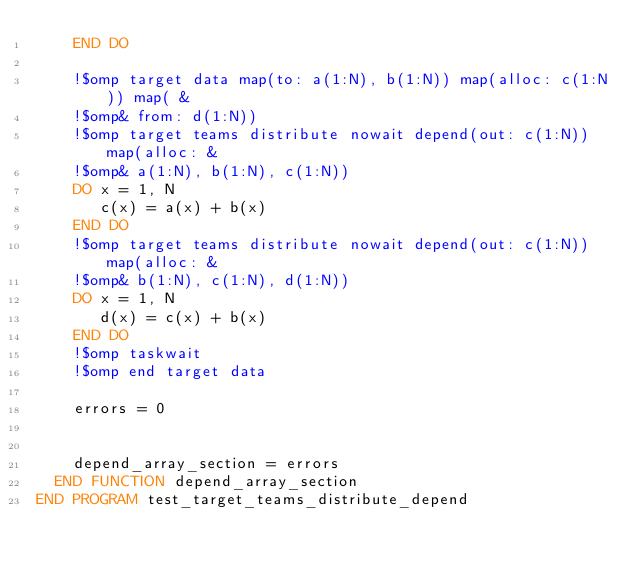<code> <loc_0><loc_0><loc_500><loc_500><_FORTRAN_>    END DO

    !$omp target data map(to: a(1:N), b(1:N)) map(alloc: c(1:N)) map( &
    !$omp& from: d(1:N))
    !$omp target teams distribute nowait depend(out: c(1:N)) map(alloc: &
    !$omp& a(1:N), b(1:N), c(1:N))
    DO x = 1, N
       c(x) = a(x) + b(x)
    END DO
    !$omp target teams distribute nowait depend(out: c(1:N)) map(alloc: &
    !$omp& b(1:N), c(1:N), d(1:N))
    DO x = 1, N
       d(x) = c(x) + b(x)
    END DO
    !$omp taskwait
    !$omp end target data

    errors = 0


    depend_array_section = errors
  END FUNCTION depend_array_section
END PROGRAM test_target_teams_distribute_depend 


</code> 